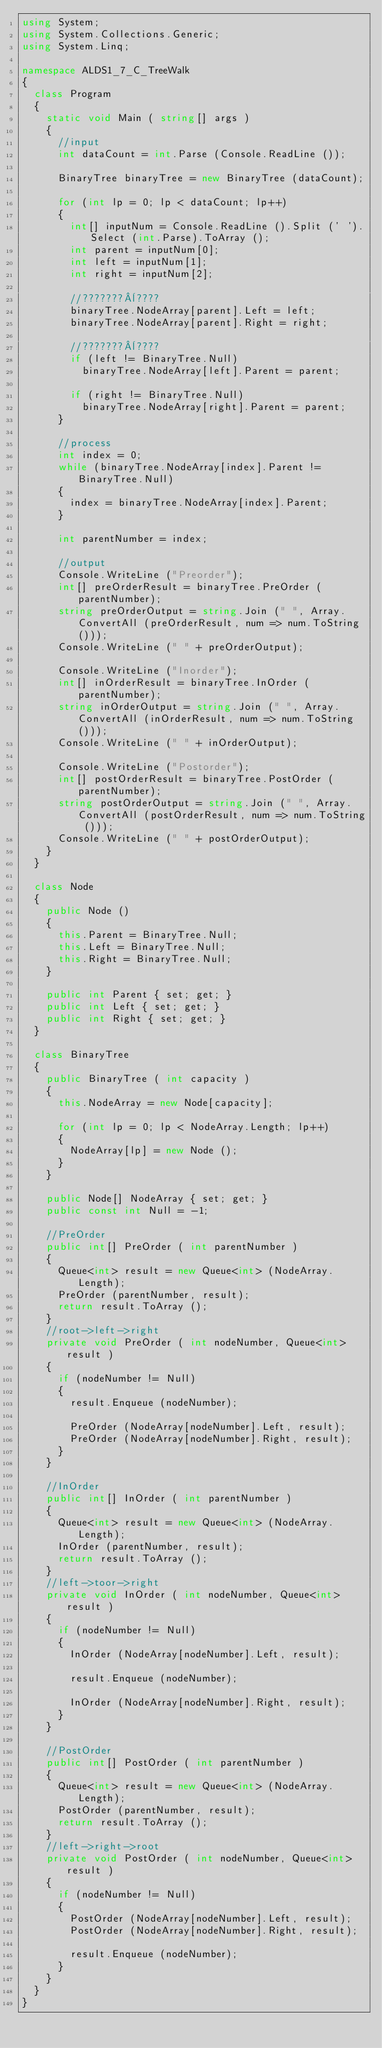<code> <loc_0><loc_0><loc_500><loc_500><_C#_>using System;
using System.Collections.Generic;
using System.Linq;

namespace ALDS1_7_C_TreeWalk
{
	class Program
	{
		static void Main ( string[] args )
		{
			//input
			int dataCount = int.Parse (Console.ReadLine ());

			BinaryTree binaryTree = new BinaryTree (dataCount);

			for (int lp = 0; lp < dataCount; lp++)
			{
				int[] inputNum = Console.ReadLine ().Split (' ').Select (int.Parse).ToArray ();
				int parent = inputNum[0];
				int left = inputNum[1];
				int right = inputNum[2];

				//???????¨????
				binaryTree.NodeArray[parent].Left = left;
				binaryTree.NodeArray[parent].Right = right;

				//???????¨????
				if (left != BinaryTree.Null)
					binaryTree.NodeArray[left].Parent = parent;

				if (right != BinaryTree.Null)
					binaryTree.NodeArray[right].Parent = parent;
			}

			//process
			int index = 0;
			while (binaryTree.NodeArray[index].Parent != BinaryTree.Null)
			{
				index = binaryTree.NodeArray[index].Parent;
			}

			int parentNumber = index;

			//output
			Console.WriteLine ("Preorder");
			int[] preOrderResult = binaryTree.PreOrder (parentNumber);
			string preOrderOutput = string.Join (" ", Array.ConvertAll (preOrderResult, num => num.ToString ()));
			Console.WriteLine (" " + preOrderOutput);

			Console.WriteLine ("Inorder");
			int[] inOrderResult = binaryTree.InOrder (parentNumber);
			string inOrderOutput = string.Join (" ", Array.ConvertAll (inOrderResult, num => num.ToString ()));
			Console.WriteLine (" " + inOrderOutput);

			Console.WriteLine ("Postorder");
			int[] postOrderResult = binaryTree.PostOrder (parentNumber);
			string postOrderOutput = string.Join (" ", Array.ConvertAll (postOrderResult, num => num.ToString ()));
			Console.WriteLine (" " + postOrderOutput);
		}
	}

	class Node
	{
		public Node ()
		{
			this.Parent = BinaryTree.Null;
			this.Left = BinaryTree.Null;
			this.Right = BinaryTree.Null;
		}

		public int Parent { set; get; }
		public int Left { set; get; }
		public int Right { set; get; }
	}

	class BinaryTree
	{
		public BinaryTree ( int capacity )
		{
			this.NodeArray = new Node[capacity];

			for (int lp = 0; lp < NodeArray.Length; lp++)
			{
				NodeArray[lp] = new Node ();
			}
		}

		public Node[] NodeArray { set; get; }
		public const int Null = -1;

		//PreOrder
		public int[] PreOrder ( int parentNumber )
		{
			Queue<int> result = new Queue<int> (NodeArray.Length);
			PreOrder (parentNumber, result);
			return result.ToArray ();
		}
		//root->left->right
		private void PreOrder ( int nodeNumber, Queue<int> result )
		{
			if (nodeNumber != Null)
			{
				result.Enqueue (nodeNumber);

				PreOrder (NodeArray[nodeNumber].Left, result);
				PreOrder (NodeArray[nodeNumber].Right, result);
			}
		}

		//InOrder
		public int[] InOrder ( int parentNumber )
		{
			Queue<int> result = new Queue<int> (NodeArray.Length);
			InOrder (parentNumber, result);
			return result.ToArray ();
		}
		//left->toor->right
		private void InOrder ( int nodeNumber, Queue<int> result )
		{
			if (nodeNumber != Null)
			{
				InOrder (NodeArray[nodeNumber].Left, result);
				
				result.Enqueue (nodeNumber);

				InOrder (NodeArray[nodeNumber].Right, result);
			}
		}

		//PostOrder
		public int[] PostOrder ( int parentNumber )
		{
			Queue<int> result = new Queue<int> (NodeArray.Length);
			PostOrder (parentNumber, result);
			return result.ToArray ();
		}
		//left->right->root
		private void PostOrder ( int nodeNumber, Queue<int> result )
		{
			if (nodeNumber != Null)
			{
				PostOrder (NodeArray[nodeNumber].Left, result);
				PostOrder (NodeArray[nodeNumber].Right, result);

				result.Enqueue (nodeNumber);
			}
		}
	}
}</code> 